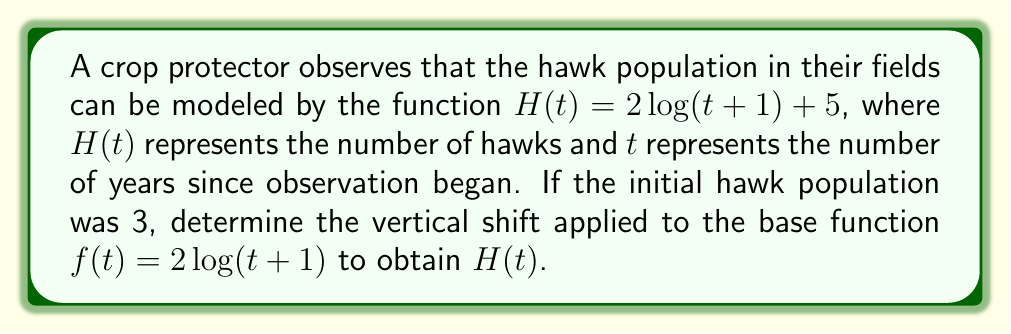Solve this math problem. 1) The general form of a vertical shift is $g(t) = f(t) + k$, where $k$ represents the vertical shift.

2) In this case, $H(t) = 2\log(t+1) + 5$ and $f(t) = 2\log(t+1)$.

3) Comparing these, we can see that $H(t) = f(t) + 5$.

4) This means the vertical shift is +5 units.

5) To verify, let's check the initial population:
   $H(0) = 2\log(0+1) + 5 = 2\log(1) + 5 = 0 + 5 = 5$

6) However, we're told the initial population was 3, not 5.

7) To make $H(0) = 3$, we need to shift the function down by 2 units.

8) Therefore, the total vertical shift from $f(t)$ to $H(t)$ is $5 - 2 = 3$ units upward.
Answer: $+3$ units 